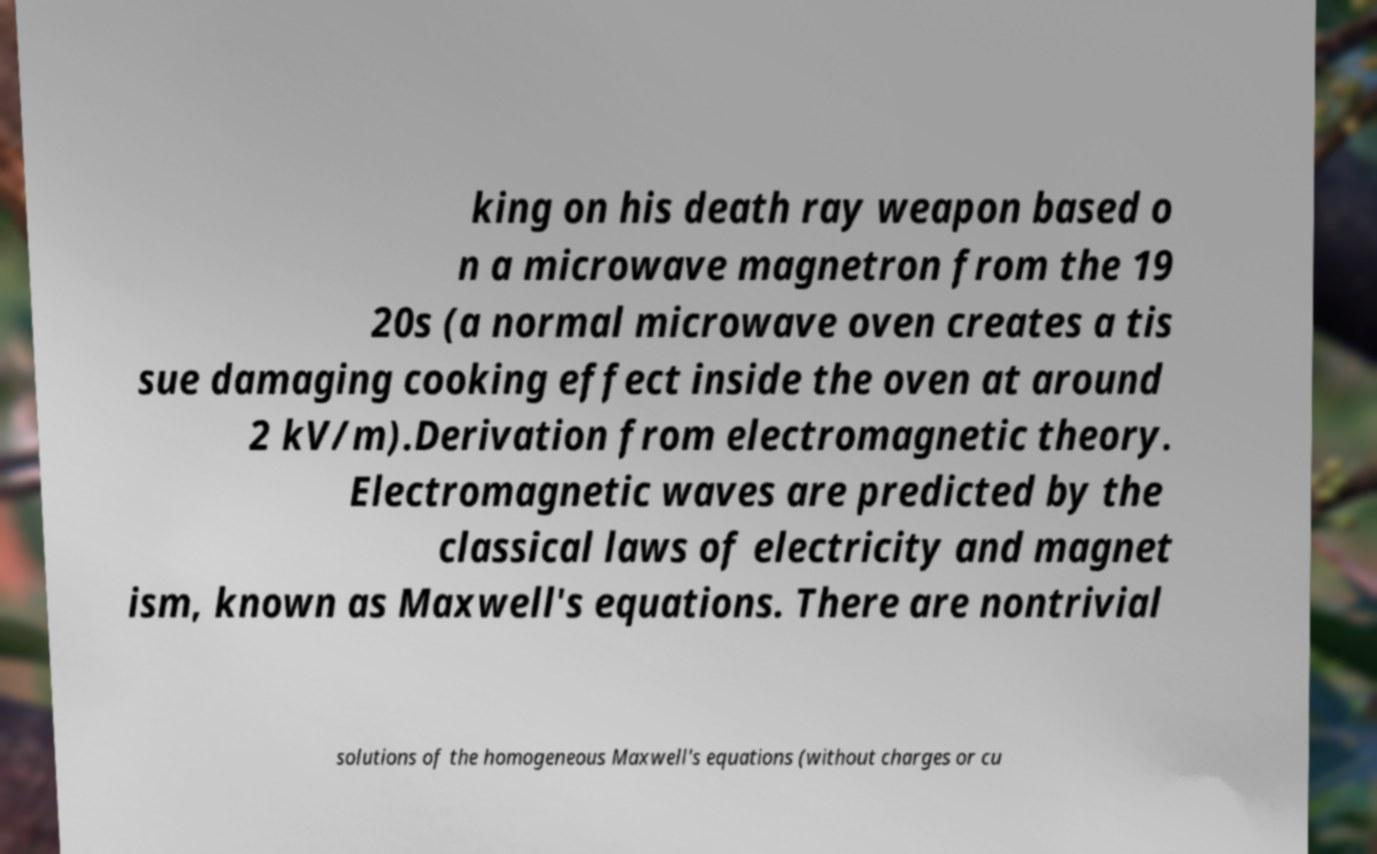Can you accurately transcribe the text from the provided image for me? king on his death ray weapon based o n a microwave magnetron from the 19 20s (a normal microwave oven creates a tis sue damaging cooking effect inside the oven at around 2 kV/m).Derivation from electromagnetic theory. Electromagnetic waves are predicted by the classical laws of electricity and magnet ism, known as Maxwell's equations. There are nontrivial solutions of the homogeneous Maxwell's equations (without charges or cu 